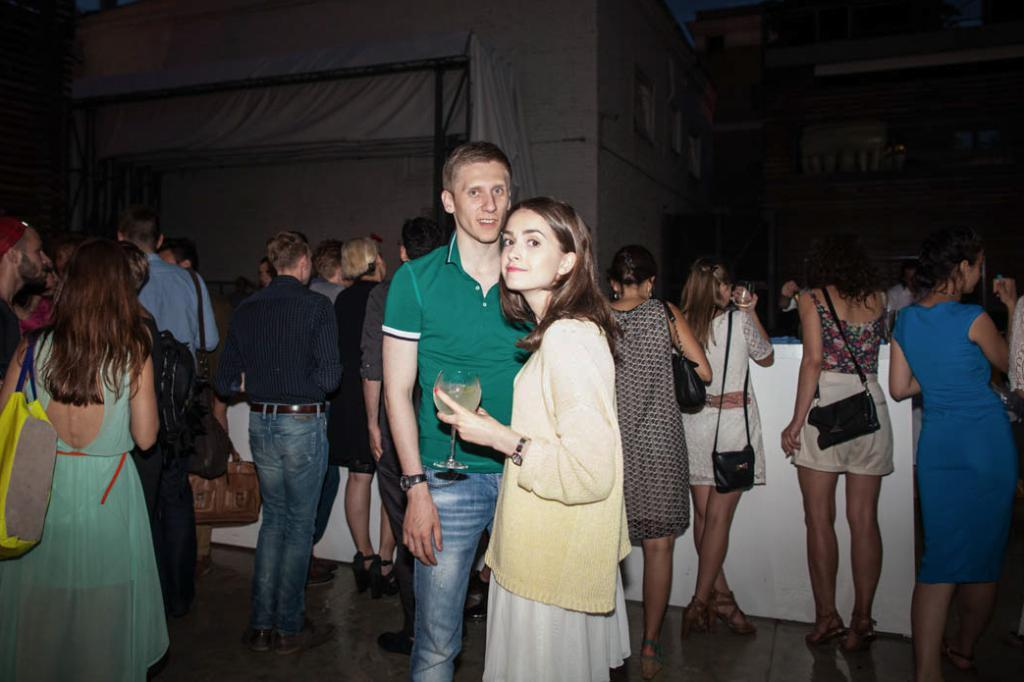How many people are visible in the image? There are two persons standing and smiling in the image. What is the person on the left holding in the image? There is a person holding a glass in the image. Can you describe the scene in the background of the image? There is a group of people standing in the background of the image, along with other items visible. How many frogs are sleeping on the gold coins in the image? There are no frogs or gold coins present in the image. 